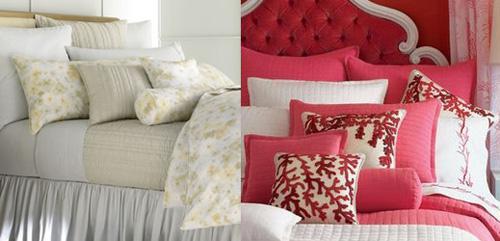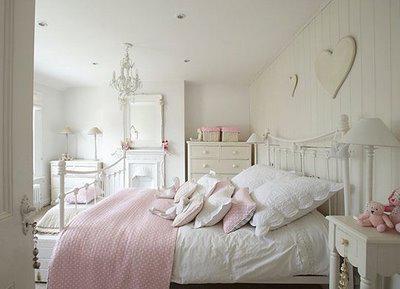The first image is the image on the left, the second image is the image on the right. For the images shown, is this caption "All bedding and pillows in one image are white." true? Answer yes or no. No. 